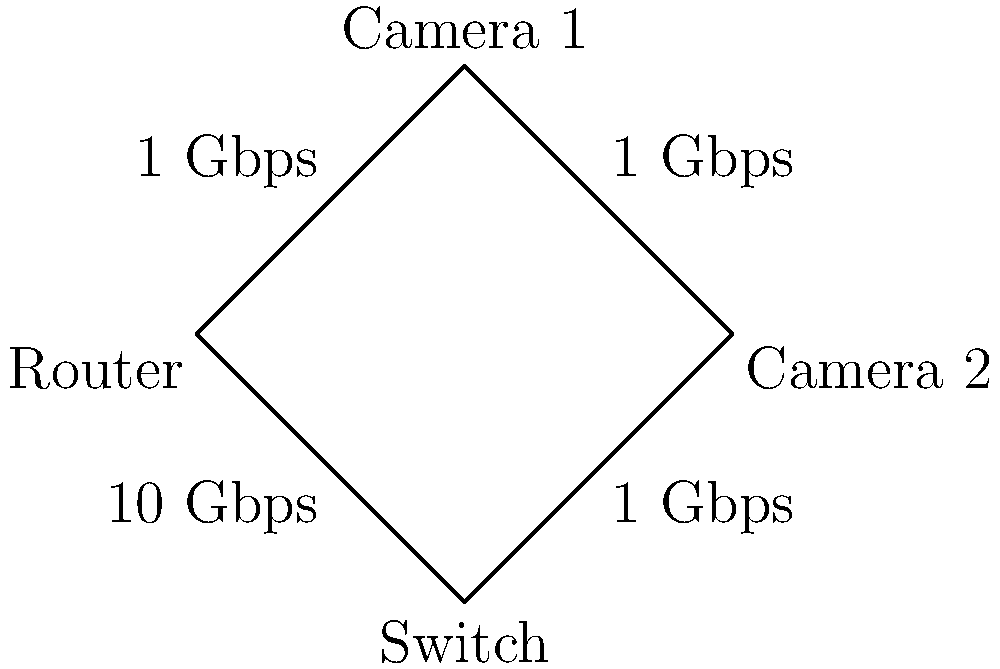Given the network topology diagram above, calculate the minimum bandwidth required at the Router to support simultaneous 4K video streaming from both Camera 1 and Camera 2. Assume that each 4K video stream requires 25 Mbps of bandwidth. What is the total bandwidth needed at the Router in Mbps? To calculate the minimum bandwidth required at the Router, we need to follow these steps:

1. Identify the number of cameras streaming:
   There are two cameras (Camera 1 and Camera 2) streaming simultaneously.

2. Determine the bandwidth requirement for each camera:
   Each 4K video stream requires 25 Mbps of bandwidth.

3. Calculate the total bandwidth needed for both cameras:
   Total bandwidth = Number of cameras × Bandwidth per camera
   $$ \text{Total bandwidth} = 2 \times 25 \text{ Mbps} = 50 \text{ Mbps} $$

4. Check if the network can support this bandwidth:
   The diagram shows that all connections between the cameras, switch, and router are 1 Gbps (1000 Mbps), which is more than sufficient to handle the 50 Mbps required for both streams.

5. Determine the bandwidth needed at the Router:
   Since both streams converge at the Router, it needs to handle the combined bandwidth of both cameras.

Therefore, the minimum bandwidth required at the Router to support simultaneous 4K video streaming from both Camera 1 and Camera 2 is 50 Mbps.
Answer: 50 Mbps 